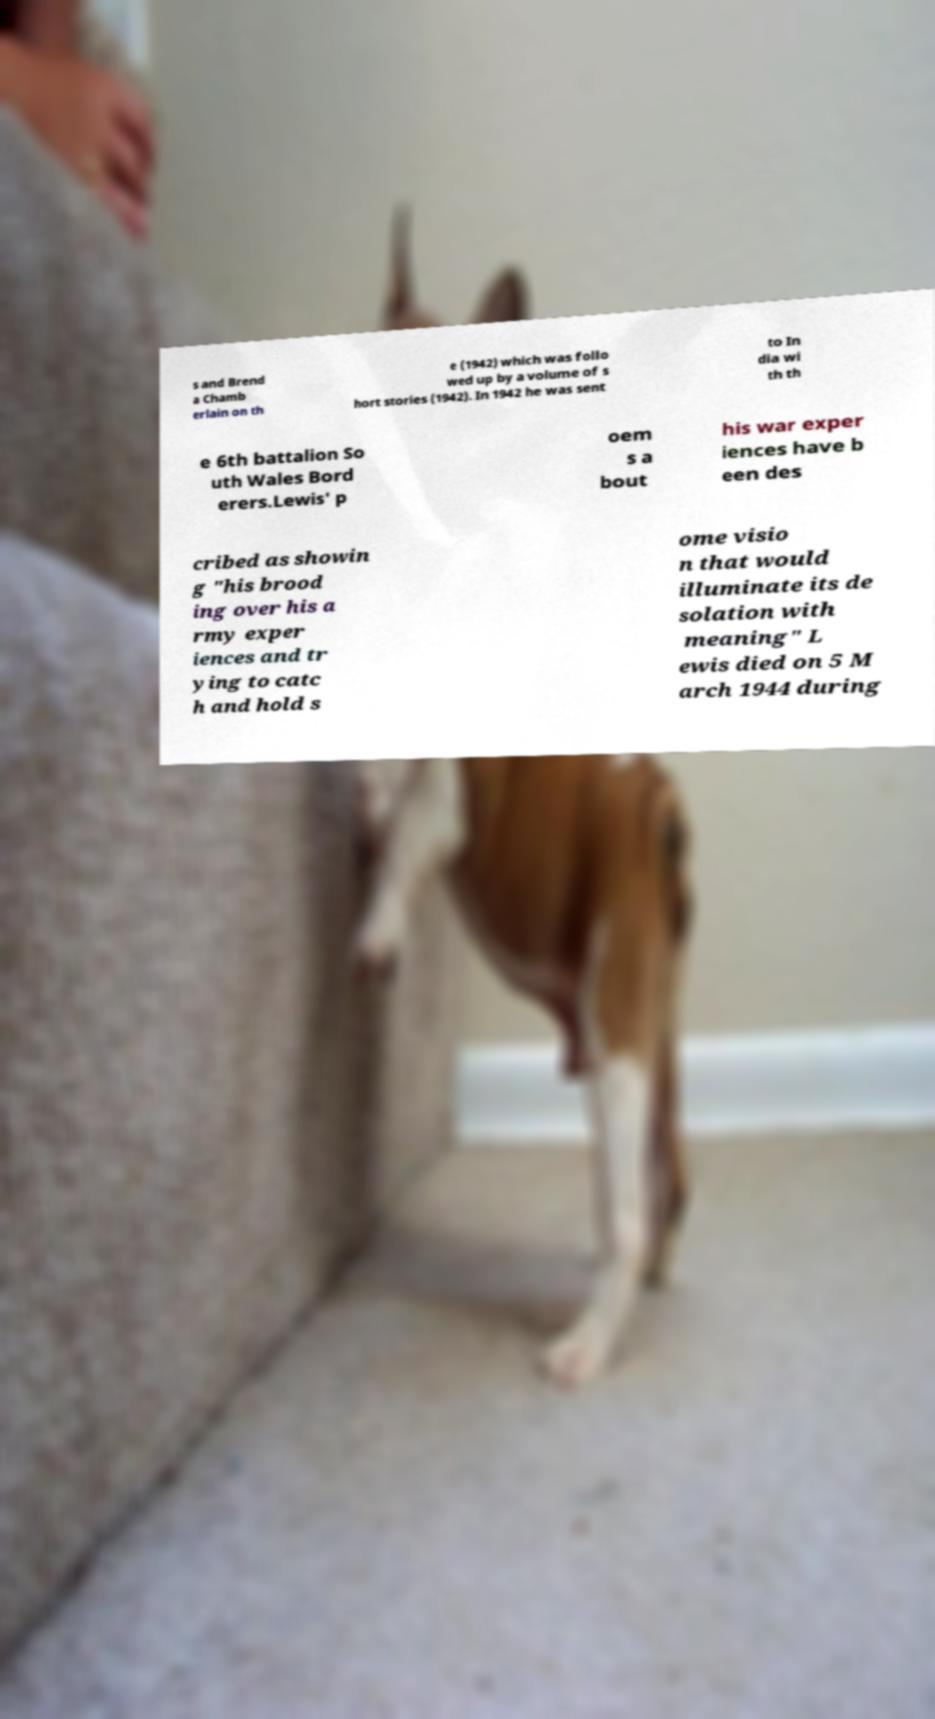What messages or text are displayed in this image? I need them in a readable, typed format. s and Brend a Chamb erlain on th e (1942) which was follo wed up by a volume of s hort stories (1942). In 1942 he was sent to In dia wi th th e 6th battalion So uth Wales Bord erers.Lewis' p oem s a bout his war exper iences have b een des cribed as showin g "his brood ing over his a rmy exper iences and tr ying to catc h and hold s ome visio n that would illuminate its de solation with meaning" L ewis died on 5 M arch 1944 during 